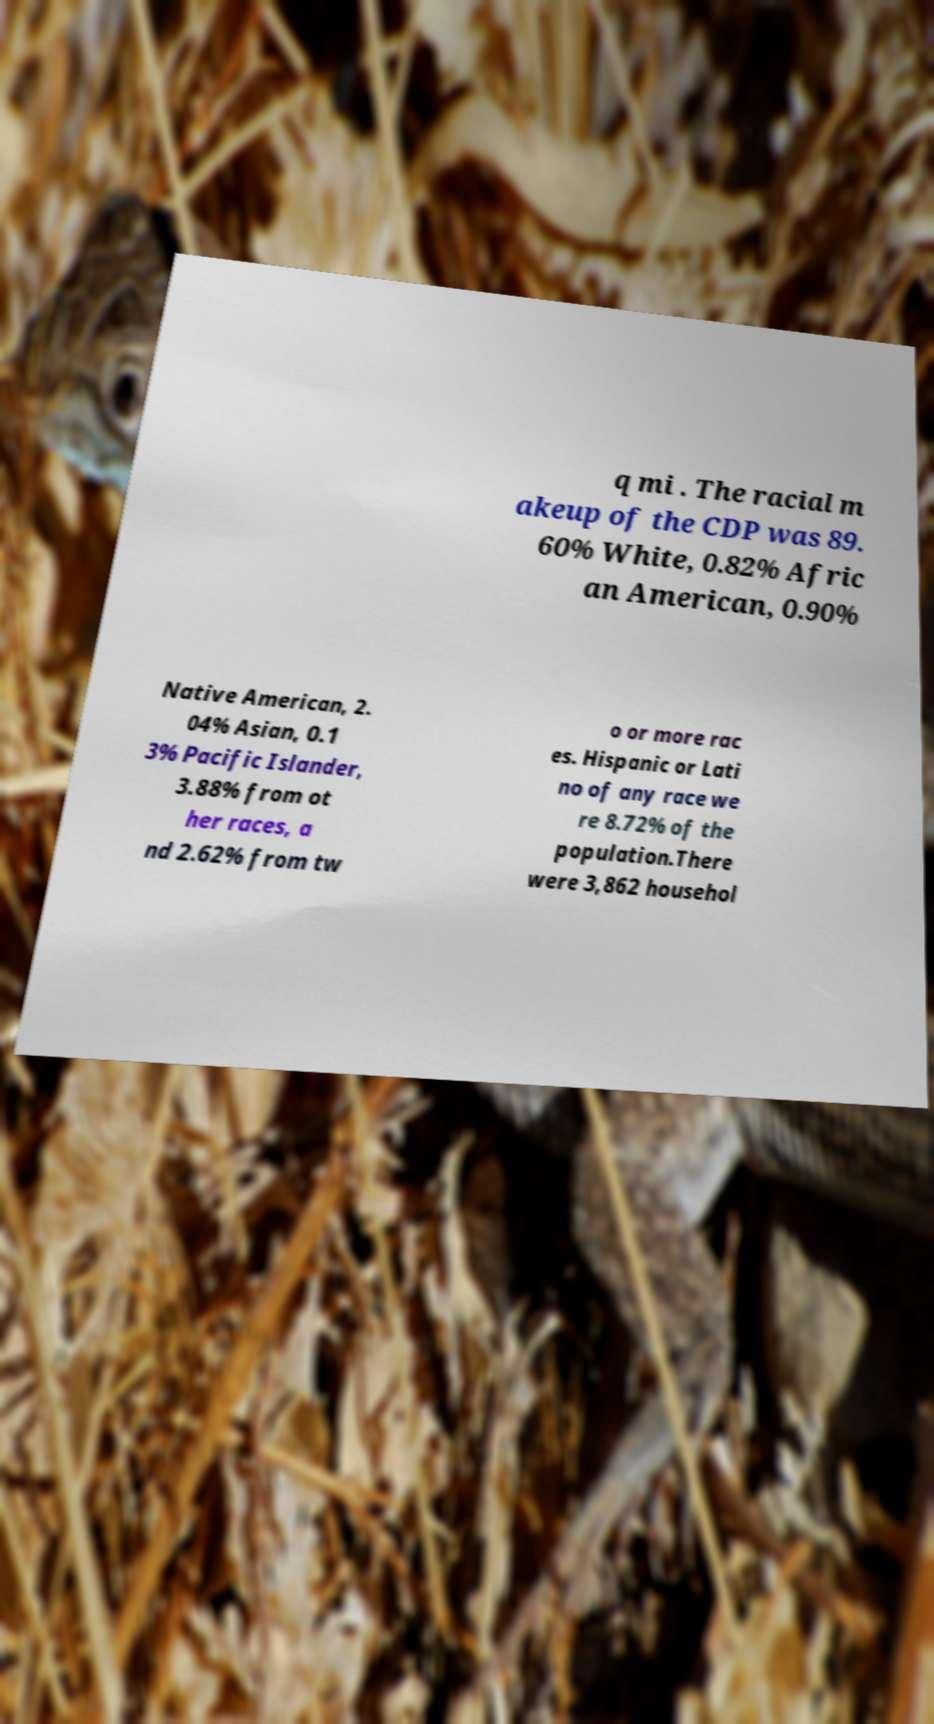Can you accurately transcribe the text from the provided image for me? q mi . The racial m akeup of the CDP was 89. 60% White, 0.82% Afric an American, 0.90% Native American, 2. 04% Asian, 0.1 3% Pacific Islander, 3.88% from ot her races, a nd 2.62% from tw o or more rac es. Hispanic or Lati no of any race we re 8.72% of the population.There were 3,862 househol 